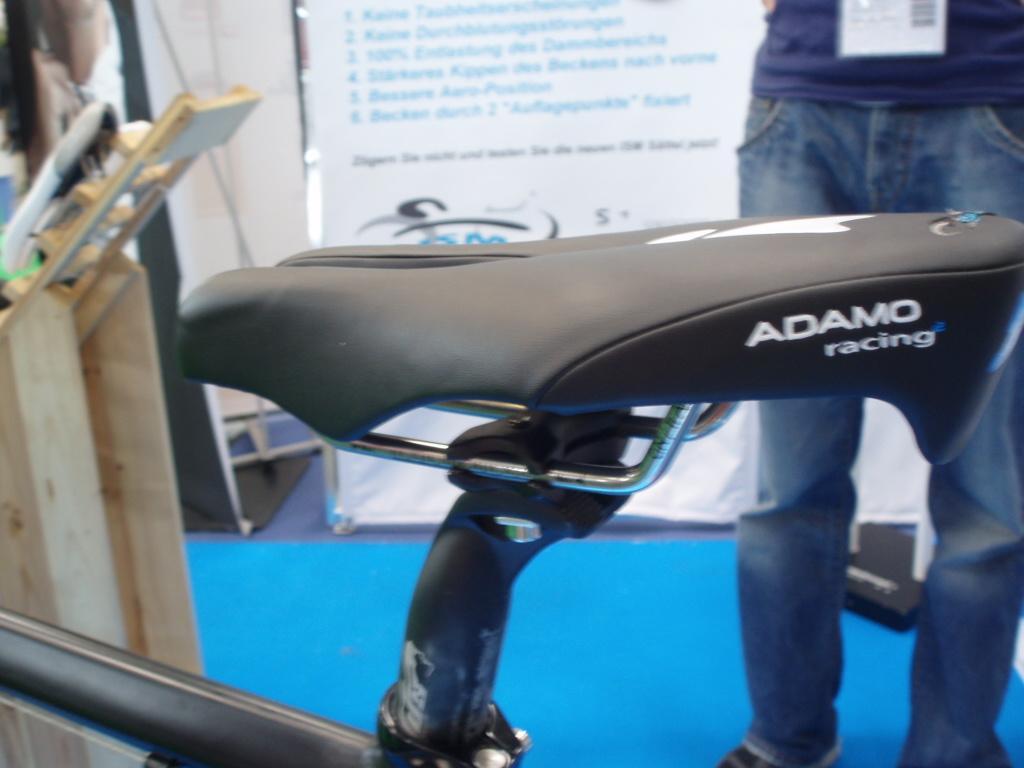Please provide a concise description of this image. In this picture I can observe a black color seat. On the right side there is a person standing, wearing a tag in his neck. In the background I can observe a poster on the board. There is some text on the poster. 